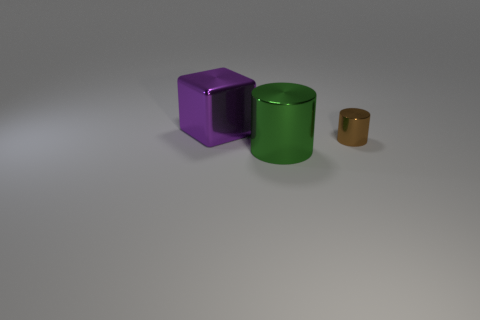Is the number of tiny brown objects to the left of the green cylinder less than the number of large cubes?
Make the answer very short. Yes. What number of other things are the same size as the brown thing?
Provide a short and direct response. 0. There is a large shiny thing left of the green cylinder; is it the same shape as the tiny brown thing?
Offer a terse response. No. Is the number of big purple metal cubes left of the cube greater than the number of green cylinders?
Your response must be concise. No. There is a object that is both left of the tiny metal object and to the right of the cube; what is its material?
Offer a very short reply. Metal. Is there anything else that is the same shape as the purple metal object?
Your response must be concise. No. How many shiny objects are left of the large green object and to the right of the large purple shiny cube?
Offer a very short reply. 0. What is the tiny cylinder made of?
Ensure brevity in your answer.  Metal. Are there an equal number of big metallic blocks that are on the left side of the big purple metal block and tiny purple matte objects?
Provide a succinct answer. Yes. What number of small brown objects have the same shape as the big green thing?
Give a very brief answer. 1. 